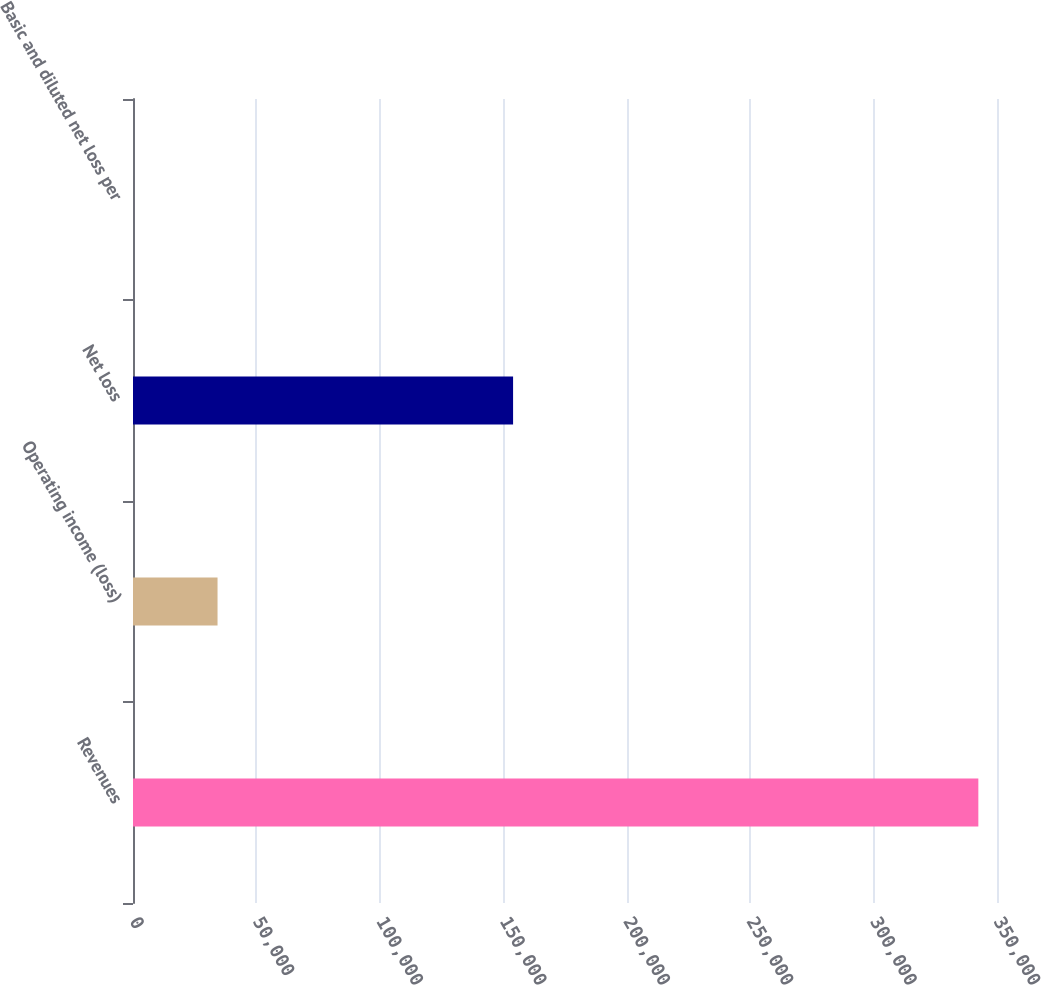Convert chart to OTSL. <chart><loc_0><loc_0><loc_500><loc_500><bar_chart><fcel>Revenues<fcel>Operating income (loss)<fcel>Net loss<fcel>Basic and diluted net loss per<nl><fcel>342441<fcel>34245.6<fcel>153967<fcel>1.69<nl></chart> 